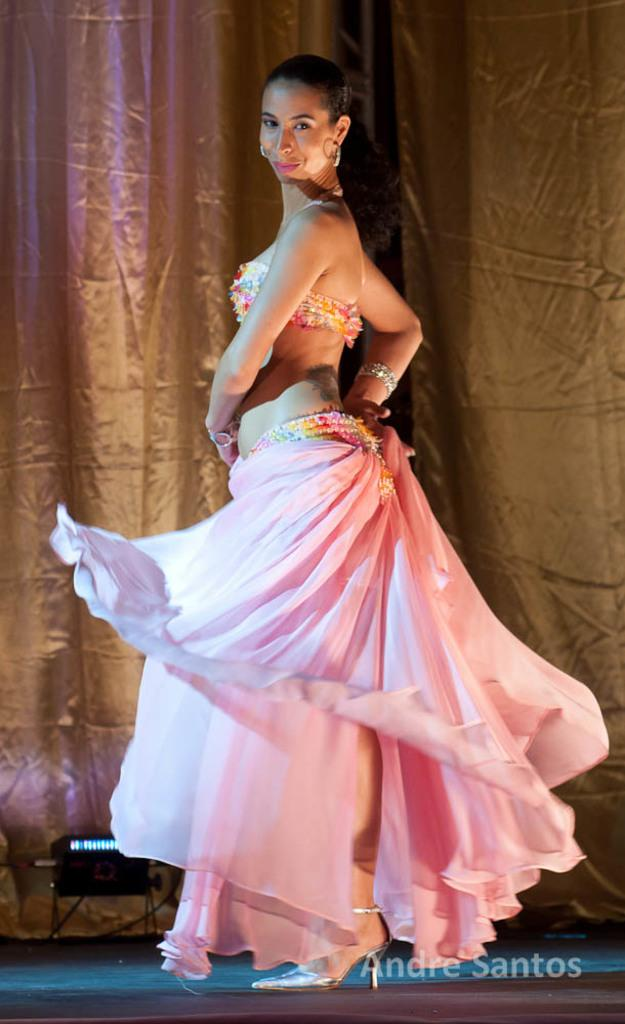What is the main subject of the image? There is a woman standing in the image. What is the woman standing on? The woman is standing on the floor. What can be seen on the floor in the background? There are electric lights on the floor in the background. What is present in the background of the image? There is a curtain in the background. What type of oatmeal is being served on the floor in the image? There is no oatmeal present in the image; the only items mentioned are a woman standing on the floor and electric lights on the floor in the background. 